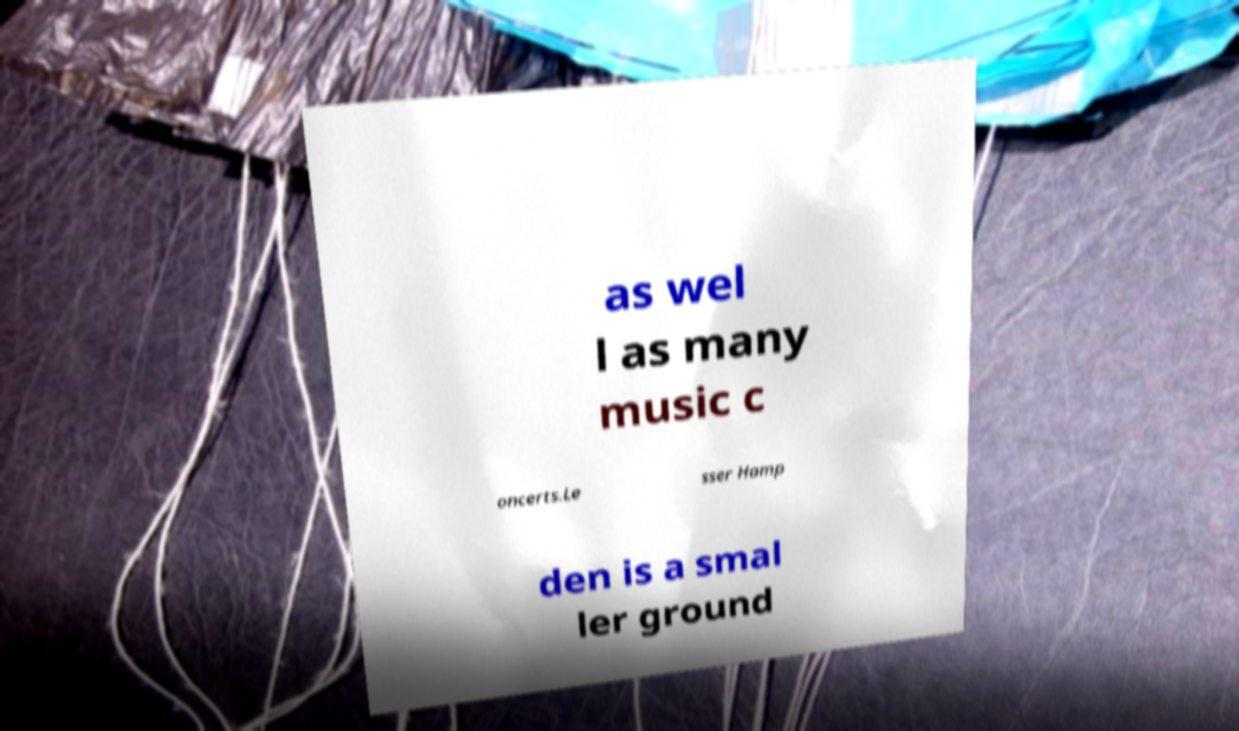Please read and relay the text visible in this image. What does it say? as wel l as many music c oncerts.Le sser Hamp den is a smal ler ground 